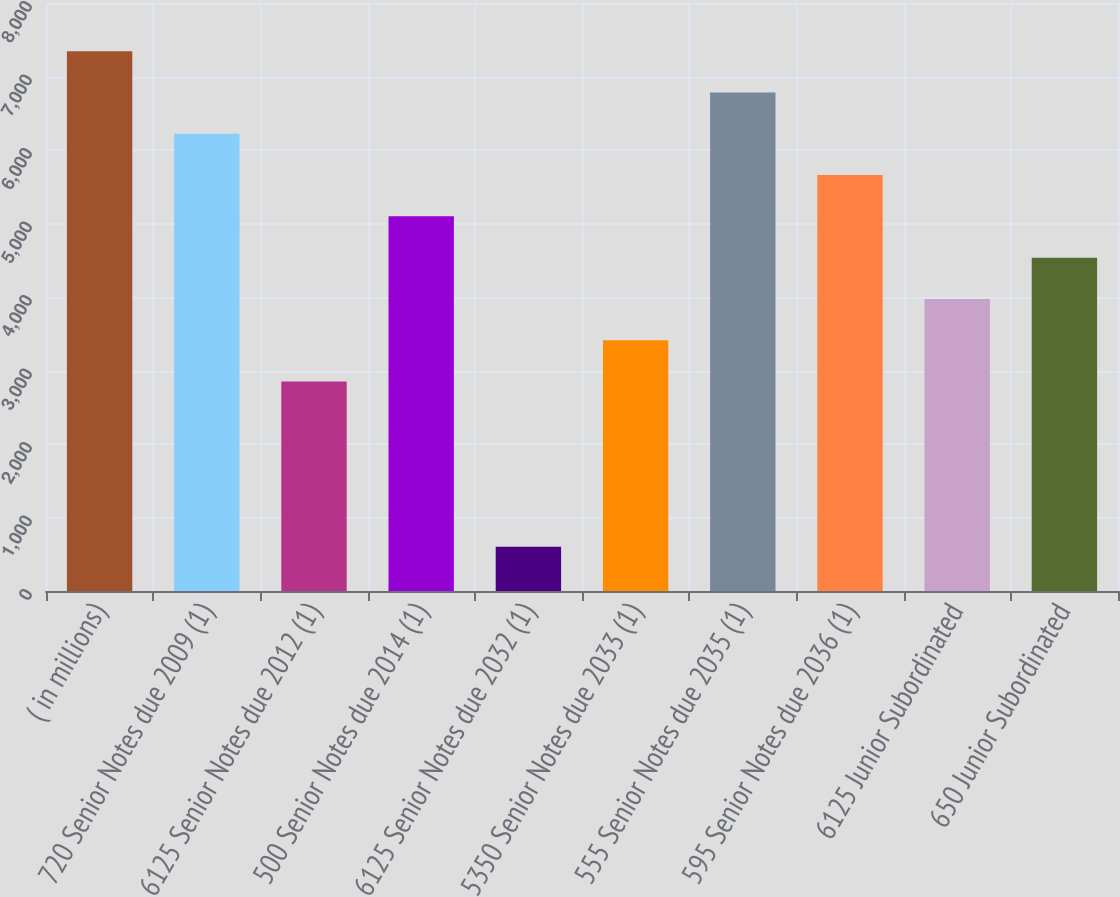<chart> <loc_0><loc_0><loc_500><loc_500><bar_chart><fcel>( in millions)<fcel>720 Senior Notes due 2009 (1)<fcel>6125 Senior Notes due 2012 (1)<fcel>500 Senior Notes due 2014 (1)<fcel>6125 Senior Notes due 2032 (1)<fcel>5350 Senior Notes due 2033 (1)<fcel>555 Senior Notes due 2035 (1)<fcel>595 Senior Notes due 2036 (1)<fcel>6125 Junior Subordinated<fcel>650 Junior Subordinated<nl><fcel>7344.7<fcel>6220.9<fcel>2849.5<fcel>5097.1<fcel>601.9<fcel>3411.4<fcel>6782.8<fcel>5659<fcel>3973.3<fcel>4535.2<nl></chart> 